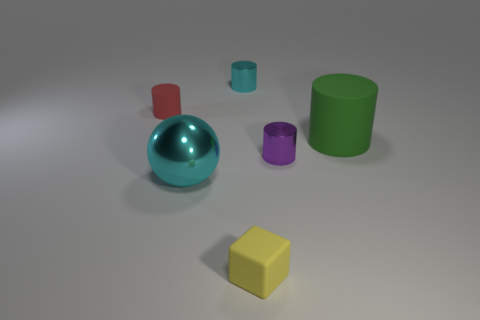Add 3 rubber cylinders. How many objects exist? 9 Subtract all tiny cyan metal cylinders. How many cylinders are left? 3 Subtract all green cylinders. How many cylinders are left? 3 Subtract 3 cylinders. How many cylinders are left? 1 Subtract 0 purple spheres. How many objects are left? 6 Subtract all blocks. How many objects are left? 5 Subtract all blue cylinders. Subtract all yellow spheres. How many cylinders are left? 4 Subtract all green spheres. How many gray blocks are left? 0 Subtract all large shiny objects. Subtract all cylinders. How many objects are left? 1 Add 2 large metallic objects. How many large metallic objects are left? 3 